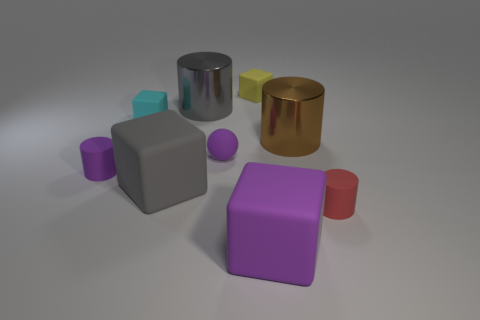Subtract all blue cylinders. Subtract all cyan spheres. How many cylinders are left? 4 Add 1 small purple rubber cylinders. How many objects exist? 10 Subtract all cylinders. How many objects are left? 5 Add 4 yellow matte things. How many yellow matte things are left? 5 Add 8 large purple matte objects. How many large purple matte objects exist? 9 Subtract 0 green cylinders. How many objects are left? 9 Subtract all cyan rubber objects. Subtract all small yellow rubber objects. How many objects are left? 7 